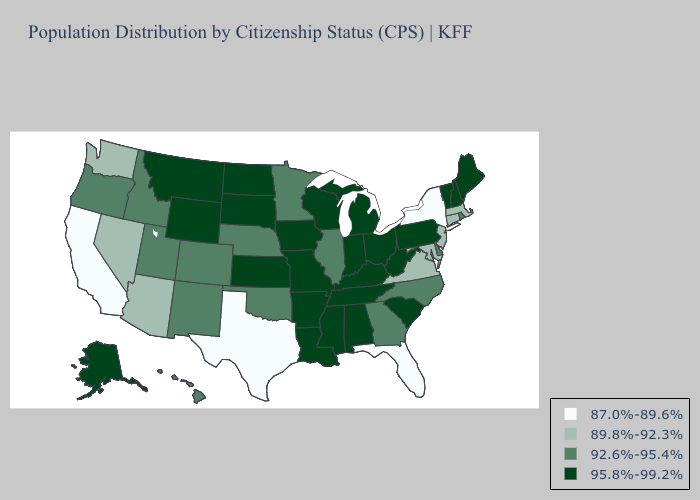Does the map have missing data?
Short answer required. No. Does North Carolina have the highest value in the USA?
Answer briefly. No. Which states hav the highest value in the Northeast?
Quick response, please. Maine, New Hampshire, Pennsylvania, Vermont. Name the states that have a value in the range 92.6%-95.4%?
Concise answer only. Colorado, Delaware, Georgia, Hawaii, Idaho, Illinois, Minnesota, Nebraska, New Mexico, North Carolina, Oklahoma, Oregon, Rhode Island, Utah. Name the states that have a value in the range 95.8%-99.2%?
Write a very short answer. Alabama, Alaska, Arkansas, Indiana, Iowa, Kansas, Kentucky, Louisiana, Maine, Michigan, Mississippi, Missouri, Montana, New Hampshire, North Dakota, Ohio, Pennsylvania, South Carolina, South Dakota, Tennessee, Vermont, West Virginia, Wisconsin, Wyoming. Does New York have the highest value in the Northeast?
Be succinct. No. What is the value of Florida?
Give a very brief answer. 87.0%-89.6%. Name the states that have a value in the range 92.6%-95.4%?
Be succinct. Colorado, Delaware, Georgia, Hawaii, Idaho, Illinois, Minnesota, Nebraska, New Mexico, North Carolina, Oklahoma, Oregon, Rhode Island, Utah. What is the value of South Dakota?
Write a very short answer. 95.8%-99.2%. Does Nebraska have the highest value in the MidWest?
Give a very brief answer. No. Does Tennessee have the highest value in the USA?
Write a very short answer. Yes. Name the states that have a value in the range 87.0%-89.6%?
Write a very short answer. California, Florida, New York, Texas. Name the states that have a value in the range 87.0%-89.6%?
Keep it brief. California, Florida, New York, Texas. What is the value of Washington?
Give a very brief answer. 89.8%-92.3%. What is the lowest value in states that border Arizona?
Answer briefly. 87.0%-89.6%. 